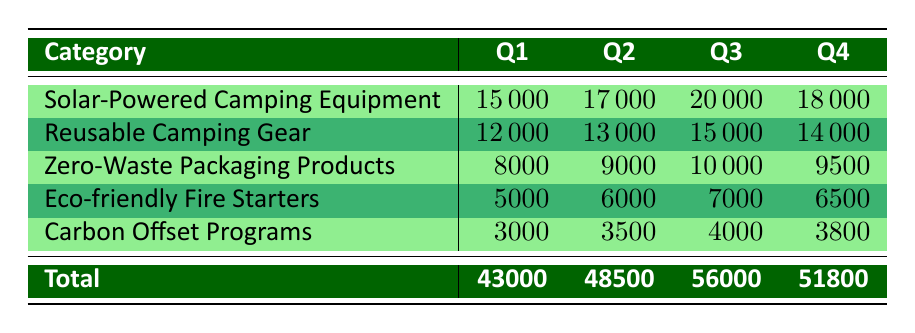What was the total revenue from Eco-friendly Fire Starters in Q3? The revenue for Eco-friendly Fire Starters in Q3 is listed directly in the table under the Q3 column, which is 7000.
Answer: 7000 Which product category had the highest revenue in Q2? Looking at the Q2 column, the highest revenue is found in the Solar-Powered Camping Equipment category with a revenue of 17000.
Answer: Solar-Powered Camping Equipment What is the total revenue for Carbon Offset Programs across all four quarters? To find the total for Carbon Offset Programs, we add the revenues from each quarter: 3000 + 3500 + 4000 + 3800 = 14300.
Answer: 14300 Did the revenue from Reusable Camping Gear increase or decrease from Q1 to Q4? The revenue from Reusable Camping Gear in Q1 is 12000, and in Q4 it is 14000. Since 14000 is greater than 12000, it indicates an increase.
Answer: Yes What was the average revenue from Zero-Waste Packaging Products for the year? To find the average for Zero-Waste Packaging Products, we add the revenues from each quarter (8000 + 9000 + 10000 + 9500 = 38500) and divide by the number of quarters (4). The average is 38500 / 4 = 9625.
Answer: 9625 Which quarter had the lowest total revenue from all Eco-friendly products combined? The total revenues for each quarter are: Q1 (43000), Q2 (48500), Q3 (56000), Q4 (51800). Comparing these totals, Q1 has the lowest revenue of 43000.
Answer: Q1 What is the difference in revenue for Solar-Powered Camping Equipment between Q3 and Q2? The revenue for Solar-Powered Camping Equipment in Q2 is 17000 and in Q3 it is 20000. The difference is 20000 - 17000 = 3000.
Answer: 3000 Was the total revenue from Eco-friendly products higher in Q4 compared to Q2? The total revenue for Q2 is 48500 and for Q4 is 51800. Since 51800 is greater than 48500, the total revenue in Q4 was higher.
Answer: Yes What percentage of the total revenue in Q3 came from Reusable Camping Gear? The total revenue in Q3 is 56000, and the revenue from Reusable Camping Gear in Q3 is 15000. To find the percentage, we calculate (15000 / 56000) * 100, which gives approximately 26.79%.
Answer: 26.79% 